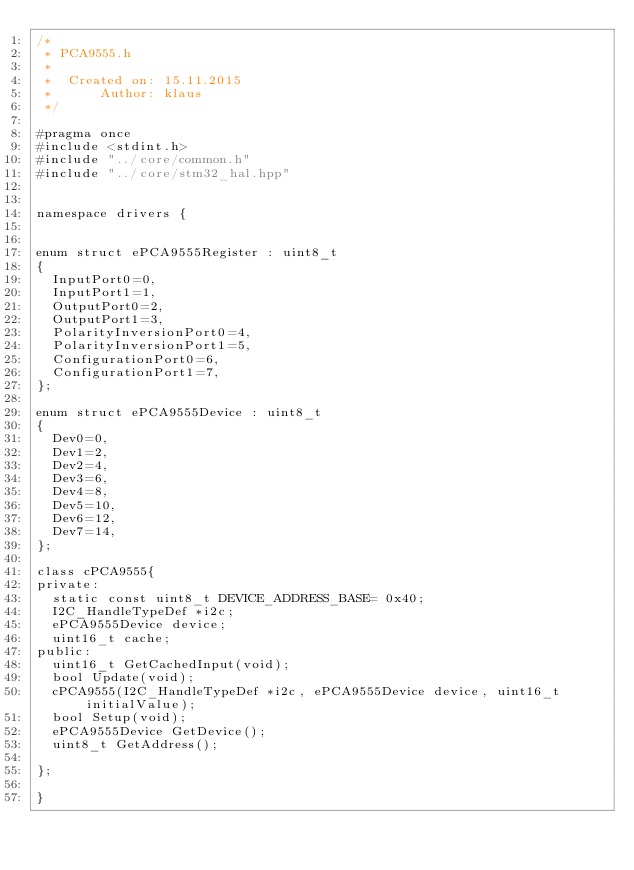Convert code to text. <code><loc_0><loc_0><loc_500><loc_500><_C_>/*
 * PCA9555.h
 *
 *  Created on: 15.11.2015
 *      Author: klaus
 */

#pragma once
#include <stdint.h>
#include "../core/common.h"
#include "../core/stm32_hal.hpp"


namespace drivers {


enum struct ePCA9555Register : uint8_t
{
	InputPort0=0,
	InputPort1=1,
	OutputPort0=2,
	OutputPort1=3,
	PolarityInversionPort0=4,
	PolarityInversionPort1=5,
	ConfigurationPort0=6,
	ConfigurationPort1=7,
};

enum struct ePCA9555Device : uint8_t
{
	Dev0=0,
	Dev1=2,
	Dev2=4,
	Dev3=6,
	Dev4=8,
	Dev5=10,
	Dev6=12,
	Dev7=14,
};

class cPCA9555{
private:
	static const uint8_t DEVICE_ADDRESS_BASE= 0x40;
	I2C_HandleTypeDef *i2c;
	ePCA9555Device device;
	uint16_t cache;
public:
	uint16_t GetCachedInput(void);
	bool Update(void);
	cPCA9555(I2C_HandleTypeDef *i2c, ePCA9555Device device, uint16_t initialValue);
	bool Setup(void);
	ePCA9555Device GetDevice();
	uint8_t GetAddress();

};

}
</code> 